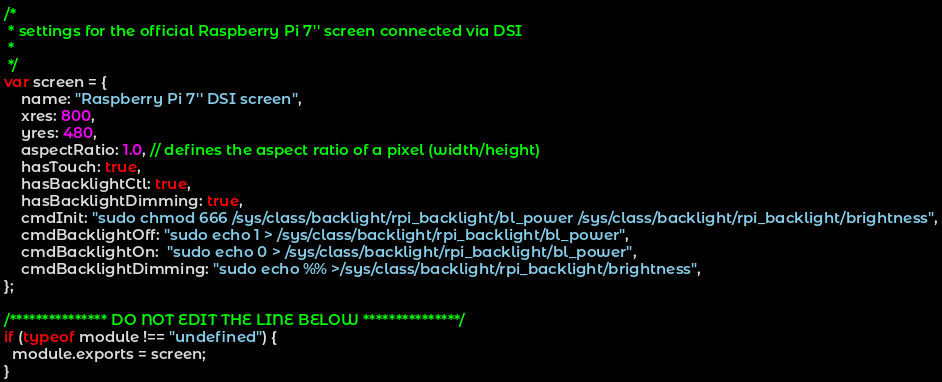<code> <loc_0><loc_0><loc_500><loc_500><_JavaScript_>/*
 * settings for the official Raspberry Pi 7'' screen connected via DSI
 *
 */
var screen = {
    name: "Raspberry Pi 7'' DSI screen",
    xres: 800,
    yres: 480,
    aspectRatio: 1.0, // defines the aspect ratio of a pixel (width/height)
    hasTouch: true,
    hasBacklightCtl: true,
    hasBacklightDimming: true,
    cmdInit: "sudo chmod 666 /sys/class/backlight/rpi_backlight/bl_power /sys/class/backlight/rpi_backlight/brightness",
    cmdBacklightOff: "sudo echo 1 > /sys/class/backlight/rpi_backlight/bl_power",
    cmdBacklightOn:  "sudo echo 0 > /sys/class/backlight/rpi_backlight/bl_power",
    cmdBacklightDimming: "sudo echo %% >/sys/class/backlight/rpi_backlight/brightness",
};

/*************** DO NOT EDIT THE LINE BELOW ***************/
if (typeof module !== "undefined") {
  module.exports = screen;
}
</code> 